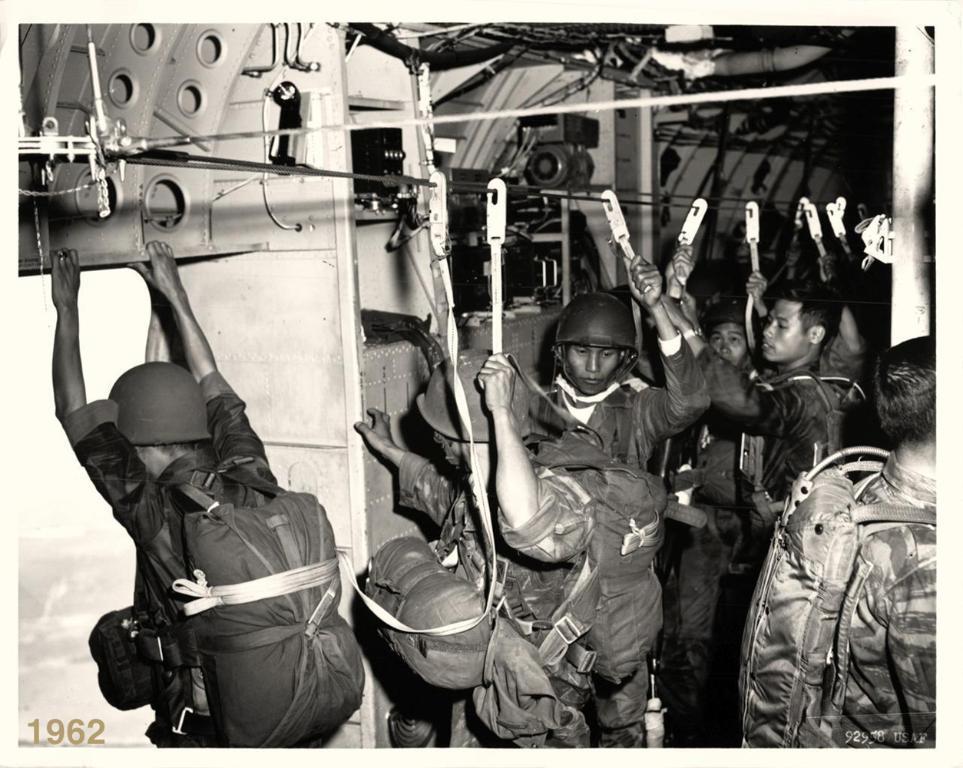Could you give a brief overview of what you see in this image? This is a black and white image and here we can see people wearing uniforms and bags and helmets and are holding hangers. In the background, we can see some rods. At the bottom, there is some text. 